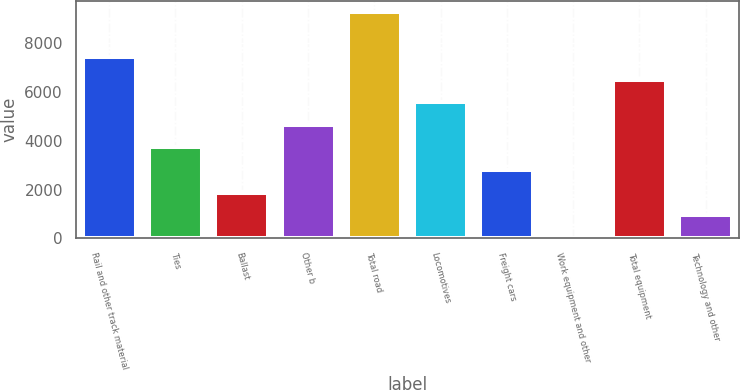<chart> <loc_0><loc_0><loc_500><loc_500><bar_chart><fcel>Rail and other track material<fcel>Ties<fcel>Ballast<fcel>Other b<fcel>Total road<fcel>Locomotives<fcel>Freight cars<fcel>Work equipment and other<fcel>Total equipment<fcel>Technology and other<nl><fcel>7436<fcel>3734<fcel>1883<fcel>4659.5<fcel>9287<fcel>5585<fcel>2808.5<fcel>32<fcel>6510.5<fcel>957.5<nl></chart> 